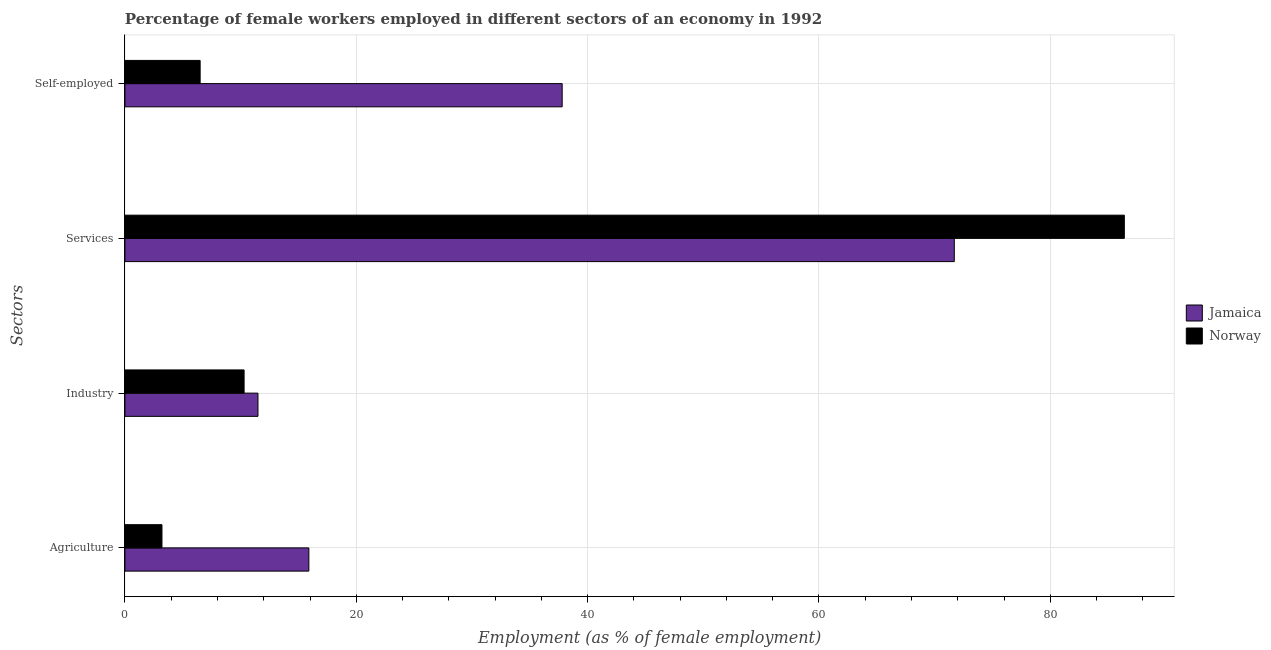How many groups of bars are there?
Offer a very short reply. 4. Are the number of bars per tick equal to the number of legend labels?
Ensure brevity in your answer.  Yes. Are the number of bars on each tick of the Y-axis equal?
Make the answer very short. Yes. What is the label of the 2nd group of bars from the top?
Keep it short and to the point. Services. What is the percentage of female workers in agriculture in Norway?
Your answer should be compact. 3.2. Across all countries, what is the maximum percentage of female workers in services?
Offer a terse response. 86.4. In which country was the percentage of self employed female workers maximum?
Provide a succinct answer. Jamaica. What is the total percentage of female workers in agriculture in the graph?
Offer a very short reply. 19.1. What is the difference between the percentage of self employed female workers in Norway and that in Jamaica?
Your response must be concise. -31.3. What is the difference between the percentage of female workers in services in Jamaica and the percentage of female workers in agriculture in Norway?
Keep it short and to the point. 68.5. What is the average percentage of female workers in services per country?
Provide a short and direct response. 79.05. What is the difference between the percentage of self employed female workers and percentage of female workers in agriculture in Jamaica?
Offer a terse response. 21.9. In how many countries, is the percentage of female workers in agriculture greater than 68 %?
Your answer should be compact. 0. What is the ratio of the percentage of female workers in industry in Jamaica to that in Norway?
Your response must be concise. 1.12. Is the percentage of female workers in agriculture in Jamaica less than that in Norway?
Keep it short and to the point. No. Is the difference between the percentage of female workers in industry in Norway and Jamaica greater than the difference between the percentage of female workers in services in Norway and Jamaica?
Keep it short and to the point. No. What is the difference between the highest and the second highest percentage of self employed female workers?
Your answer should be compact. 31.3. What is the difference between the highest and the lowest percentage of female workers in agriculture?
Your answer should be compact. 12.7. Is the sum of the percentage of self employed female workers in Norway and Jamaica greater than the maximum percentage of female workers in industry across all countries?
Offer a very short reply. Yes. Is it the case that in every country, the sum of the percentage of female workers in industry and percentage of female workers in services is greater than the sum of percentage of self employed female workers and percentage of female workers in agriculture?
Provide a short and direct response. No. What does the 1st bar from the bottom in Agriculture represents?
Offer a very short reply. Jamaica. Is it the case that in every country, the sum of the percentage of female workers in agriculture and percentage of female workers in industry is greater than the percentage of female workers in services?
Give a very brief answer. No. Are all the bars in the graph horizontal?
Offer a terse response. Yes. What is the difference between two consecutive major ticks on the X-axis?
Give a very brief answer. 20. Does the graph contain any zero values?
Ensure brevity in your answer.  No. Does the graph contain grids?
Your answer should be compact. Yes. Where does the legend appear in the graph?
Provide a succinct answer. Center right. How many legend labels are there?
Ensure brevity in your answer.  2. How are the legend labels stacked?
Make the answer very short. Vertical. What is the title of the graph?
Provide a succinct answer. Percentage of female workers employed in different sectors of an economy in 1992. Does "Cayman Islands" appear as one of the legend labels in the graph?
Give a very brief answer. No. What is the label or title of the X-axis?
Your answer should be very brief. Employment (as % of female employment). What is the label or title of the Y-axis?
Make the answer very short. Sectors. What is the Employment (as % of female employment) of Jamaica in Agriculture?
Your answer should be compact. 15.9. What is the Employment (as % of female employment) in Norway in Agriculture?
Ensure brevity in your answer.  3.2. What is the Employment (as % of female employment) of Jamaica in Industry?
Offer a very short reply. 11.5. What is the Employment (as % of female employment) in Norway in Industry?
Offer a very short reply. 10.3. What is the Employment (as % of female employment) in Jamaica in Services?
Offer a very short reply. 71.7. What is the Employment (as % of female employment) of Norway in Services?
Make the answer very short. 86.4. What is the Employment (as % of female employment) of Jamaica in Self-employed?
Give a very brief answer. 37.8. What is the Employment (as % of female employment) of Norway in Self-employed?
Offer a terse response. 6.5. Across all Sectors, what is the maximum Employment (as % of female employment) of Jamaica?
Your answer should be compact. 71.7. Across all Sectors, what is the maximum Employment (as % of female employment) of Norway?
Offer a very short reply. 86.4. Across all Sectors, what is the minimum Employment (as % of female employment) in Jamaica?
Provide a succinct answer. 11.5. Across all Sectors, what is the minimum Employment (as % of female employment) in Norway?
Give a very brief answer. 3.2. What is the total Employment (as % of female employment) in Jamaica in the graph?
Your answer should be very brief. 136.9. What is the total Employment (as % of female employment) of Norway in the graph?
Offer a terse response. 106.4. What is the difference between the Employment (as % of female employment) of Norway in Agriculture and that in Industry?
Provide a short and direct response. -7.1. What is the difference between the Employment (as % of female employment) of Jamaica in Agriculture and that in Services?
Provide a succinct answer. -55.8. What is the difference between the Employment (as % of female employment) in Norway in Agriculture and that in Services?
Your answer should be compact. -83.2. What is the difference between the Employment (as % of female employment) of Jamaica in Agriculture and that in Self-employed?
Make the answer very short. -21.9. What is the difference between the Employment (as % of female employment) in Jamaica in Industry and that in Services?
Ensure brevity in your answer.  -60.2. What is the difference between the Employment (as % of female employment) of Norway in Industry and that in Services?
Provide a succinct answer. -76.1. What is the difference between the Employment (as % of female employment) in Jamaica in Industry and that in Self-employed?
Give a very brief answer. -26.3. What is the difference between the Employment (as % of female employment) in Norway in Industry and that in Self-employed?
Your answer should be compact. 3.8. What is the difference between the Employment (as % of female employment) in Jamaica in Services and that in Self-employed?
Your response must be concise. 33.9. What is the difference between the Employment (as % of female employment) in Norway in Services and that in Self-employed?
Offer a very short reply. 79.9. What is the difference between the Employment (as % of female employment) of Jamaica in Agriculture and the Employment (as % of female employment) of Norway in Services?
Make the answer very short. -70.5. What is the difference between the Employment (as % of female employment) in Jamaica in Agriculture and the Employment (as % of female employment) in Norway in Self-employed?
Your response must be concise. 9.4. What is the difference between the Employment (as % of female employment) of Jamaica in Industry and the Employment (as % of female employment) of Norway in Services?
Your answer should be compact. -74.9. What is the difference between the Employment (as % of female employment) in Jamaica in Services and the Employment (as % of female employment) in Norway in Self-employed?
Your response must be concise. 65.2. What is the average Employment (as % of female employment) in Jamaica per Sectors?
Ensure brevity in your answer.  34.23. What is the average Employment (as % of female employment) in Norway per Sectors?
Your answer should be compact. 26.6. What is the difference between the Employment (as % of female employment) in Jamaica and Employment (as % of female employment) in Norway in Agriculture?
Your answer should be compact. 12.7. What is the difference between the Employment (as % of female employment) of Jamaica and Employment (as % of female employment) of Norway in Services?
Give a very brief answer. -14.7. What is the difference between the Employment (as % of female employment) in Jamaica and Employment (as % of female employment) in Norway in Self-employed?
Keep it short and to the point. 31.3. What is the ratio of the Employment (as % of female employment) in Jamaica in Agriculture to that in Industry?
Your answer should be very brief. 1.38. What is the ratio of the Employment (as % of female employment) in Norway in Agriculture to that in Industry?
Provide a succinct answer. 0.31. What is the ratio of the Employment (as % of female employment) of Jamaica in Agriculture to that in Services?
Make the answer very short. 0.22. What is the ratio of the Employment (as % of female employment) of Norway in Agriculture to that in Services?
Make the answer very short. 0.04. What is the ratio of the Employment (as % of female employment) in Jamaica in Agriculture to that in Self-employed?
Your answer should be compact. 0.42. What is the ratio of the Employment (as % of female employment) in Norway in Agriculture to that in Self-employed?
Your response must be concise. 0.49. What is the ratio of the Employment (as % of female employment) in Jamaica in Industry to that in Services?
Provide a succinct answer. 0.16. What is the ratio of the Employment (as % of female employment) of Norway in Industry to that in Services?
Provide a short and direct response. 0.12. What is the ratio of the Employment (as % of female employment) of Jamaica in Industry to that in Self-employed?
Keep it short and to the point. 0.3. What is the ratio of the Employment (as % of female employment) in Norway in Industry to that in Self-employed?
Your answer should be very brief. 1.58. What is the ratio of the Employment (as % of female employment) in Jamaica in Services to that in Self-employed?
Provide a succinct answer. 1.9. What is the ratio of the Employment (as % of female employment) of Norway in Services to that in Self-employed?
Your answer should be very brief. 13.29. What is the difference between the highest and the second highest Employment (as % of female employment) of Jamaica?
Make the answer very short. 33.9. What is the difference between the highest and the second highest Employment (as % of female employment) of Norway?
Provide a short and direct response. 76.1. What is the difference between the highest and the lowest Employment (as % of female employment) in Jamaica?
Offer a terse response. 60.2. What is the difference between the highest and the lowest Employment (as % of female employment) of Norway?
Your answer should be compact. 83.2. 